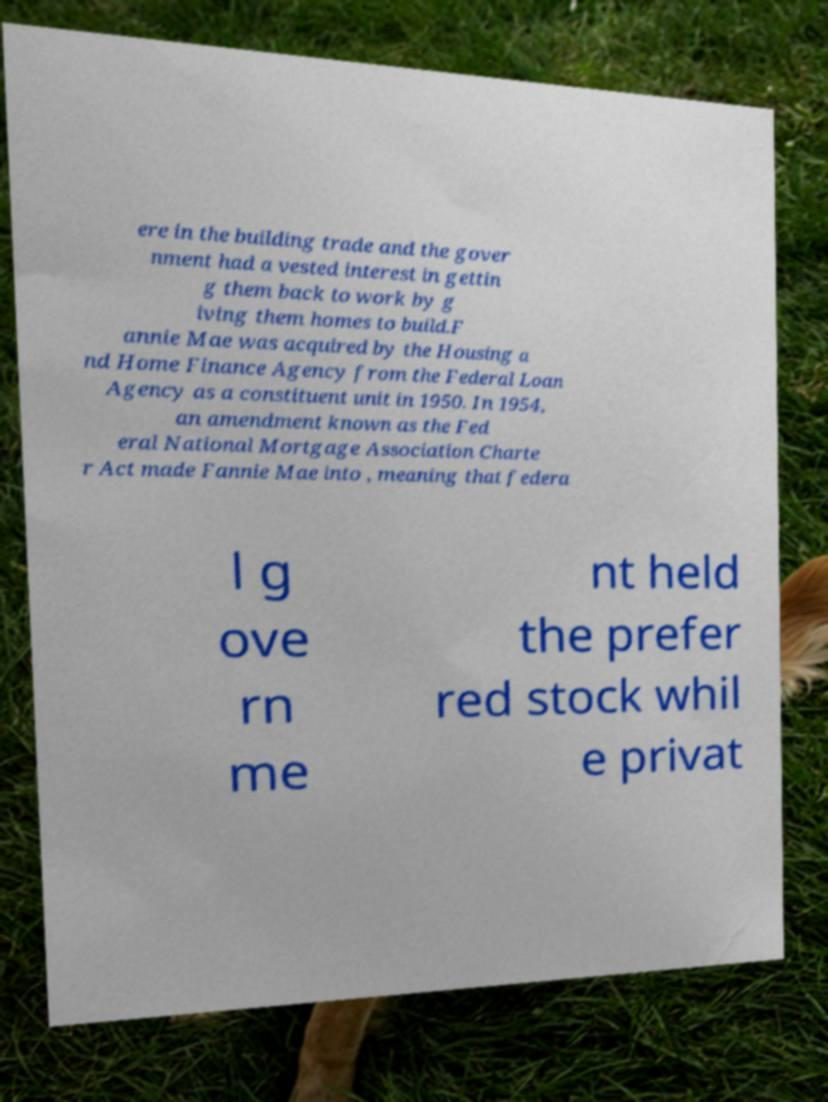Can you read and provide the text displayed in the image?This photo seems to have some interesting text. Can you extract and type it out for me? ere in the building trade and the gover nment had a vested interest in gettin g them back to work by g iving them homes to build.F annie Mae was acquired by the Housing a nd Home Finance Agency from the Federal Loan Agency as a constituent unit in 1950. In 1954, an amendment known as the Fed eral National Mortgage Association Charte r Act made Fannie Mae into , meaning that federa l g ove rn me nt held the prefer red stock whil e privat 